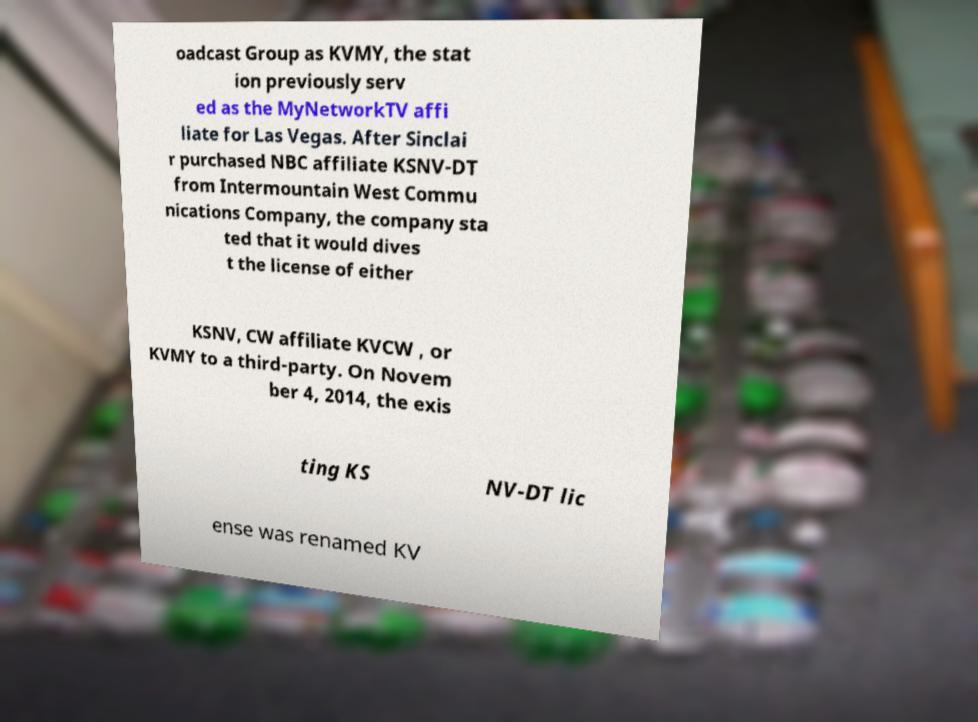For documentation purposes, I need the text within this image transcribed. Could you provide that? oadcast Group as KVMY, the stat ion previously serv ed as the MyNetworkTV affi liate for Las Vegas. After Sinclai r purchased NBC affiliate KSNV-DT from Intermountain West Commu nications Company, the company sta ted that it would dives t the license of either KSNV, CW affiliate KVCW , or KVMY to a third-party. On Novem ber 4, 2014, the exis ting KS NV-DT lic ense was renamed KV 